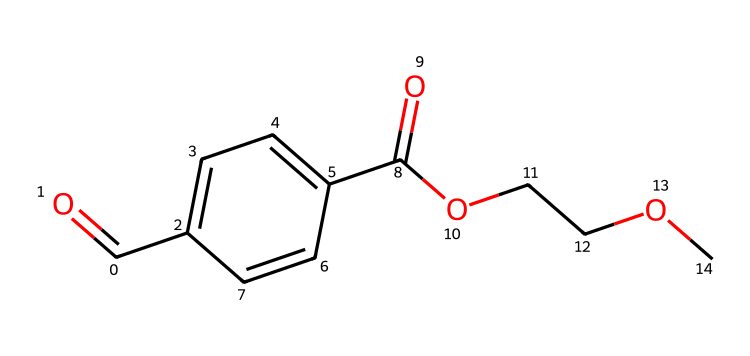How many carbon atoms are present in the structure? By analyzing the SMILES representation, I can count the number of carbon (C) atoms. The structure shows a total of 11 carbon atoms, which can be identified by each 'C' in the SMILES string.
Answer: 11 What functional groups can be identified in this chemical? The SMILES indicates the presence of two major functional groups: ester and carboxylic acid. The 'C(=O)O' portion shows a carboxylic acid, and 'C(=O)OCCO' denotes the ester group in the structure.
Answer: ester, carboxylic acid What is the molecular formula of the compound? By interpreting the SMILES, I can derive the molecular formula. The components indicate it has 10 carbons (C), 10 hydrogens (H), 4 oxygens (O), leading to the formula C10H10O4.
Answer: C10H10O4 What type of polymer does this compound represent? Given that PET is characterized as a polyester made from the reaction of ethylene glycol and terephthalic acid, I can identify this compound as a polyester. The presence of ester links in the structure supports this classification.
Answer: polyester Which atoms are involved in forming ester bonds? Looking closely at the structure, the ester bonds are formed between the oxygen atom (O) that connects the alcohol group (OCC) and the carbonyl groups (C(=O)). These parts indicate where the ester linkages occur in the polymer chain.
Answer: oxygen, carbon How many total hydrogen atoms are in the molecule? By counting the hydrogen (H) atoms associated with the carbon and functional groups depicted in the SMILES, I conclude that there are 10 hydrogen atoms total in the molecular structure.
Answer: 10 What primary property makes PET suitable for high-altitude balloon films? PET's high tensile strength and dimensional stability under varying temperatures and pressures give it excellent durability. Analyzing the structure reflects its capability to endure the harsh conditions at high altitudes.
Answer: durability 